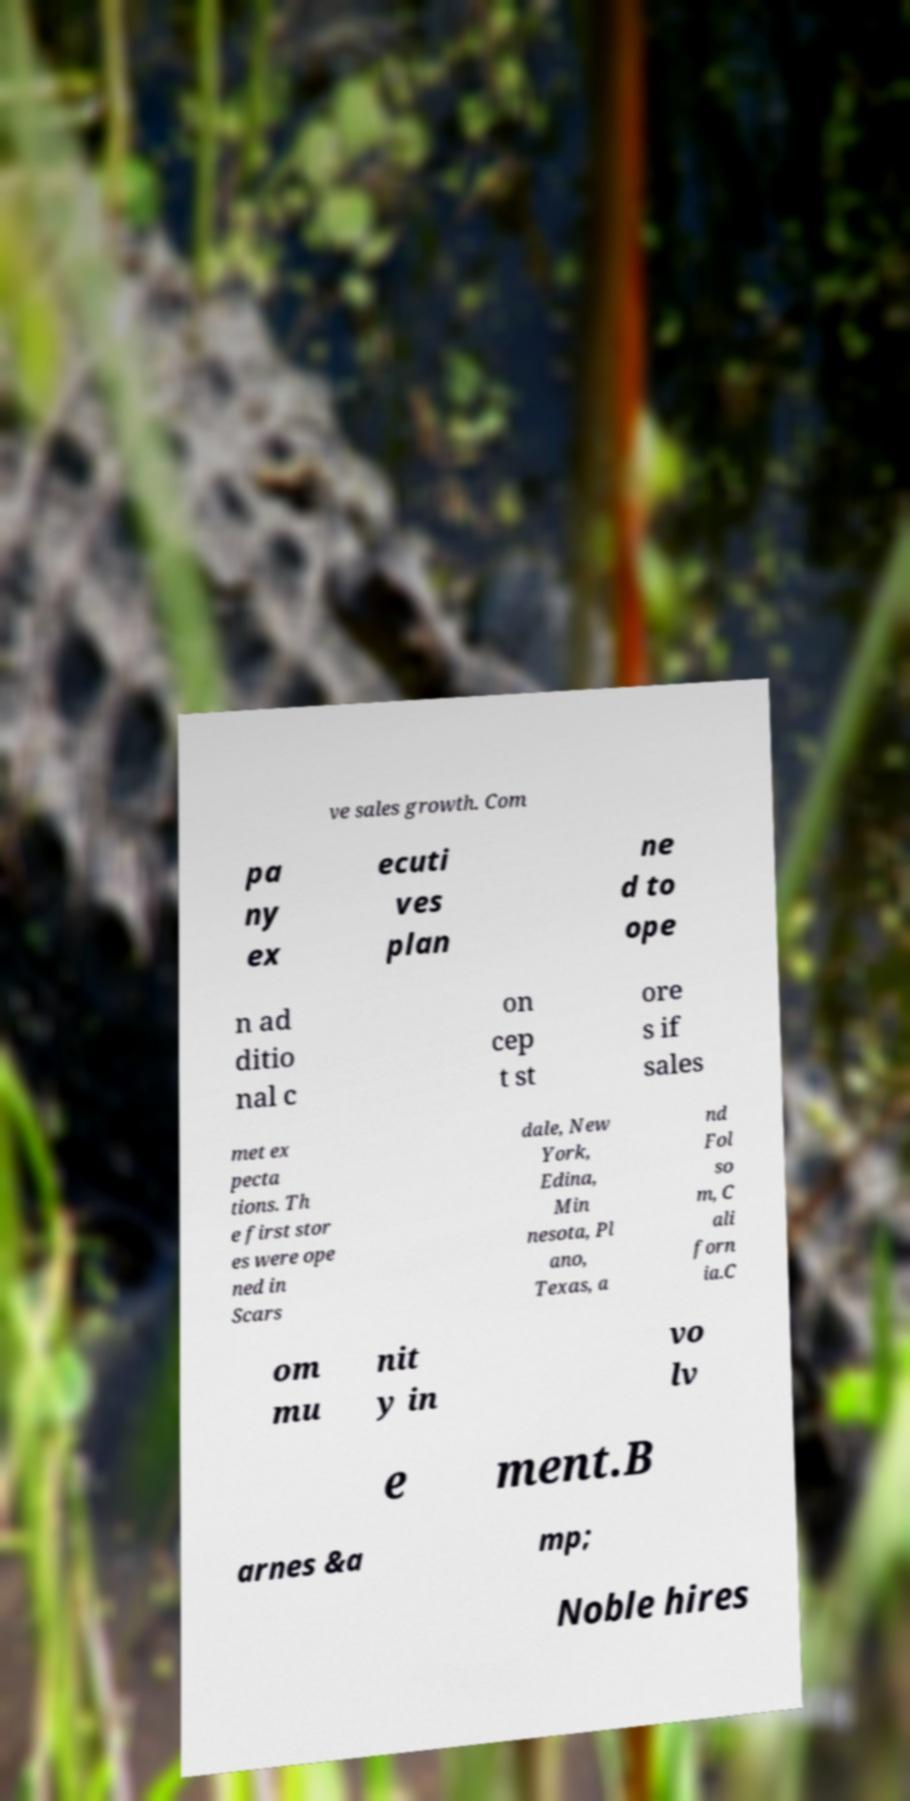Please identify and transcribe the text found in this image. ve sales growth. Com pa ny ex ecuti ves plan ne d to ope n ad ditio nal c on cep t st ore s if sales met ex pecta tions. Th e first stor es were ope ned in Scars dale, New York, Edina, Min nesota, Pl ano, Texas, a nd Fol so m, C ali forn ia.C om mu nit y in vo lv e ment.B arnes &a mp; Noble hires 